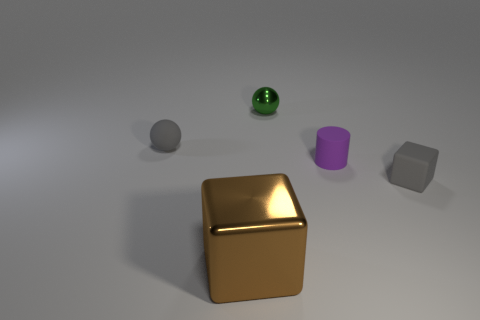Add 3 tiny cylinders. How many objects exist? 8 Subtract all cylinders. How many objects are left? 4 Add 2 tiny gray rubber blocks. How many tiny gray rubber blocks exist? 3 Subtract 0 yellow cubes. How many objects are left? 5 Subtract all small green metallic spheres. Subtract all small matte objects. How many objects are left? 1 Add 3 metal spheres. How many metal spheres are left? 4 